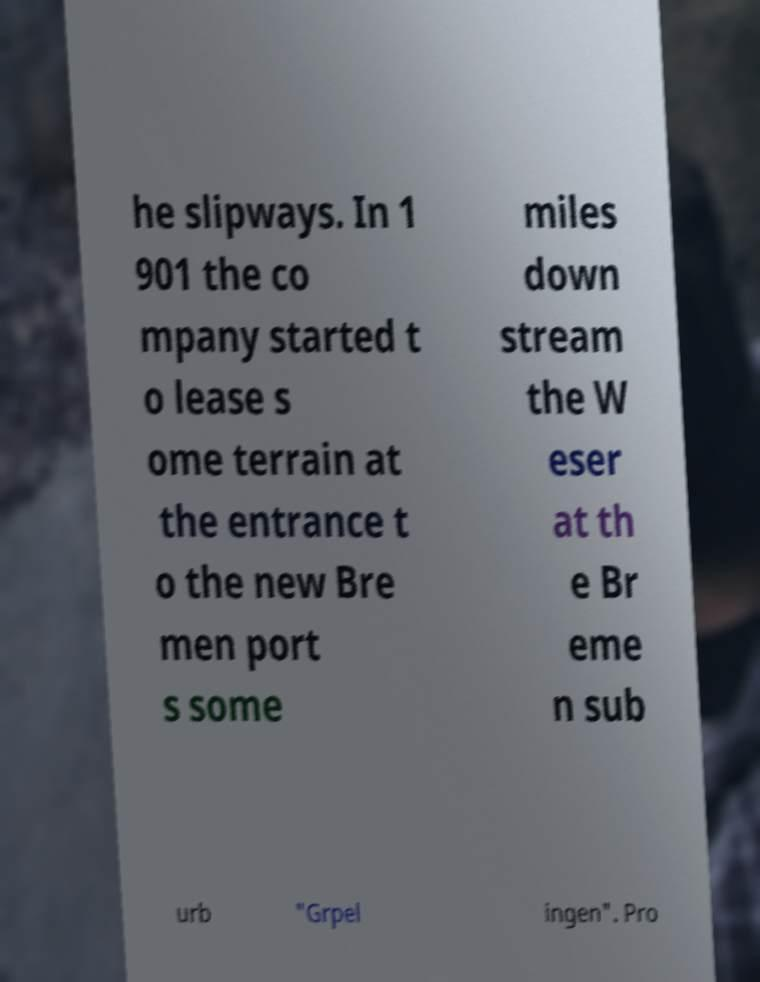Can you read and provide the text displayed in the image?This photo seems to have some interesting text. Can you extract and type it out for me? he slipways. In 1 901 the co mpany started t o lease s ome terrain at the entrance t o the new Bre men port s some miles down stream the W eser at th e Br eme n sub urb "Grpel ingen". Pro 